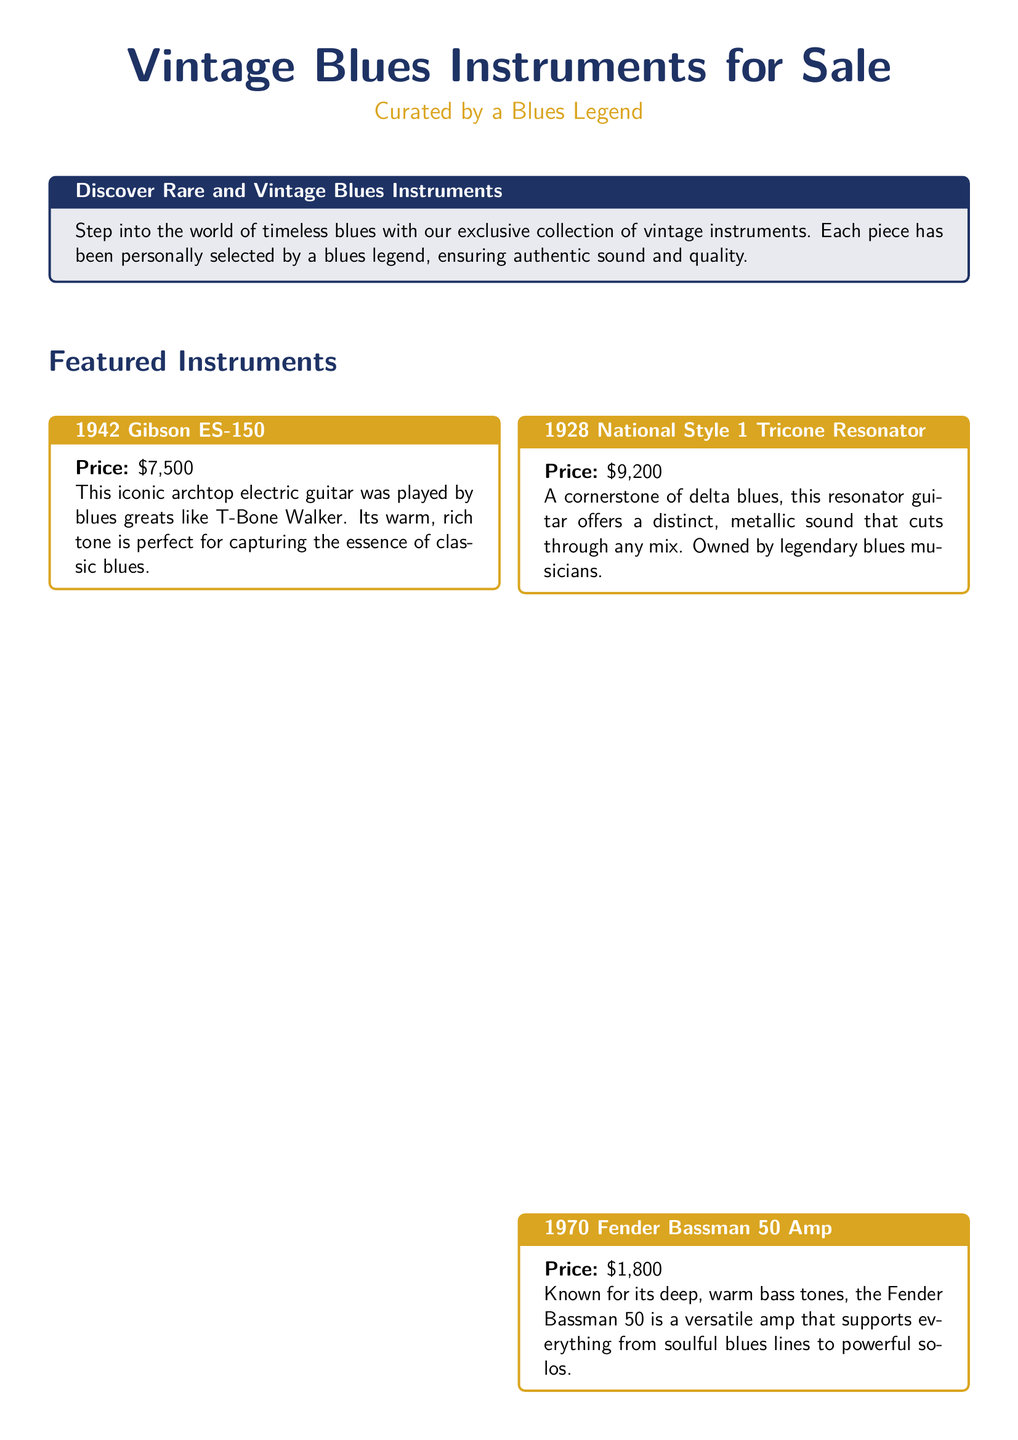What is the title of the advertisement? The title of the advertisement is prominently displayed at the top of the document.
Answer: Vintage Blues Instruments for Sale Who curated the collection? The document states that the instruments were personally curated by a notable figure.
Answer: A Blues Legend What is the price of the 1942 Gibson ES-150? The document specifies the price for this instrument in its description.
Answer: $7,500 What type of instrument is the 1928 National Style 1? This information is included in the description of the featured instruments in the document.
Answer: Resonator guitar What is included with every instrument purchase? The advertisement mentions additional items provided with the purchase, which adds value.
Answer: Certificate of authenticity How much does the 1970 Fender Bassman 50 Amp cost? The document lists the price of this amplifier as part of the featured instruments section.
Answer: $1,800 What type of sound does the 1930s C.G. Conn Saxophone deliver? This is described in the instrument’s features in the document.
Answer: Smooth, expressive tone What is the purpose of the testimonial included in the document? The testimonial serves to provide social proof and enhance the advertisement's appeal.
Answer: To praise the collection's authenticity and quality What does the advertisement encourage people to do? The last statement indicates an action requested from the audience.
Answer: Own a part of music history 